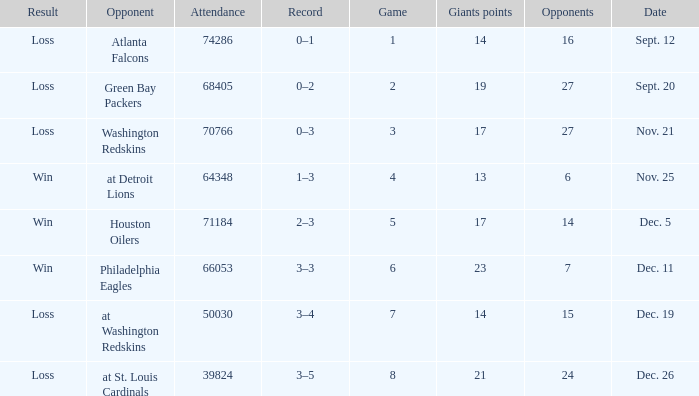What is the record when the opponent is washington redskins? 0–3. 